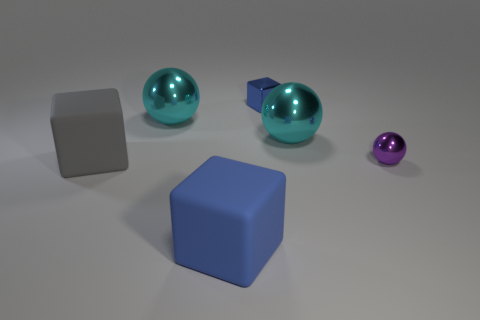What number of cyan spheres are in front of the big metal ball to the left of the blue rubber thing? There is a single cyan sphere positioned directly in front of the large metal sphere, located to the left of the vibrant blue rubber cube. 